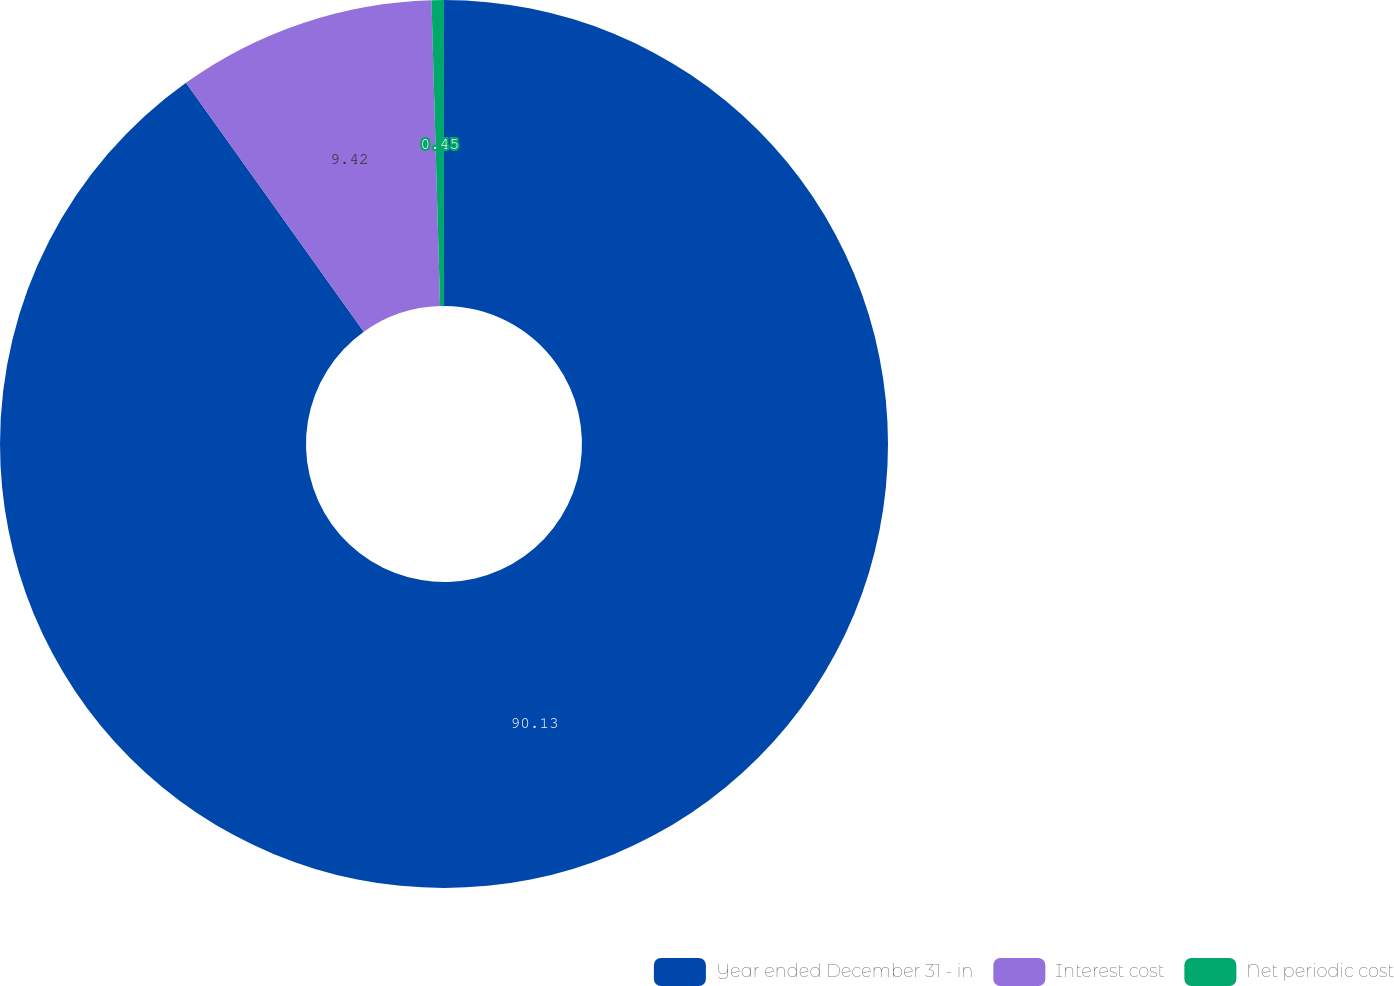<chart> <loc_0><loc_0><loc_500><loc_500><pie_chart><fcel>Year ended December 31 - in<fcel>Interest cost<fcel>Net periodic cost<nl><fcel>90.13%<fcel>9.42%<fcel>0.45%<nl></chart> 